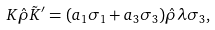<formula> <loc_0><loc_0><loc_500><loc_500>K \hat { \rho } \tilde { K } ^ { \prime } = ( a _ { 1 } \sigma _ { 1 } + a _ { 3 } \sigma _ { 3 } ) \hat { \rho } \lambda \sigma _ { 3 } ,</formula> 